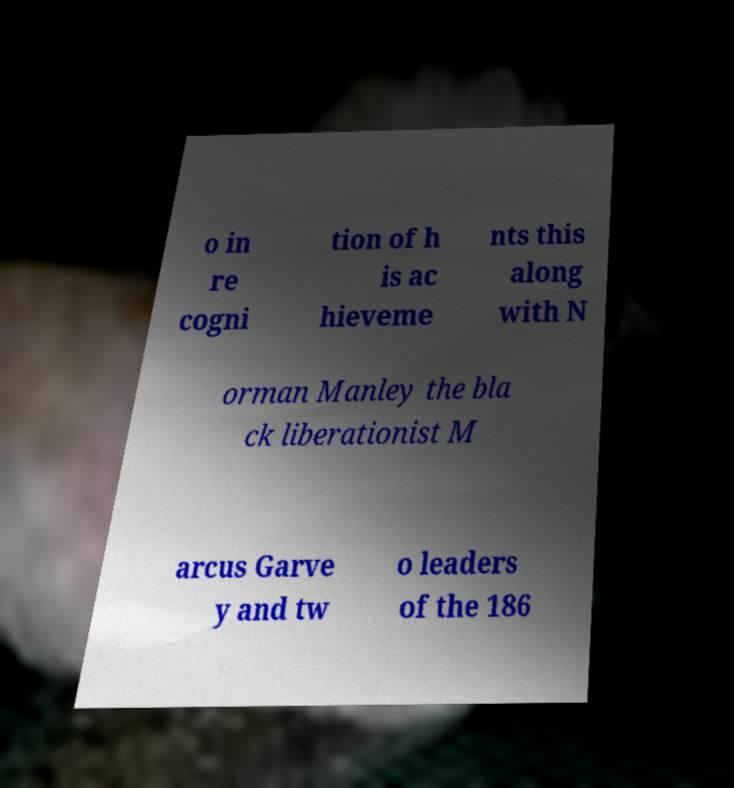Can you accurately transcribe the text from the provided image for me? o in re cogni tion of h is ac hieveme nts this along with N orman Manley the bla ck liberationist M arcus Garve y and tw o leaders of the 186 